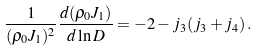<formula> <loc_0><loc_0><loc_500><loc_500>\frac { 1 } { ( \rho _ { 0 } J _ { 1 } ) ^ { 2 } } \frac { d ( \rho _ { 0 } J _ { 1 } ) } { d \ln D } = - 2 - j _ { 3 } ( j _ { 3 } + j _ { 4 } ) \, .</formula> 